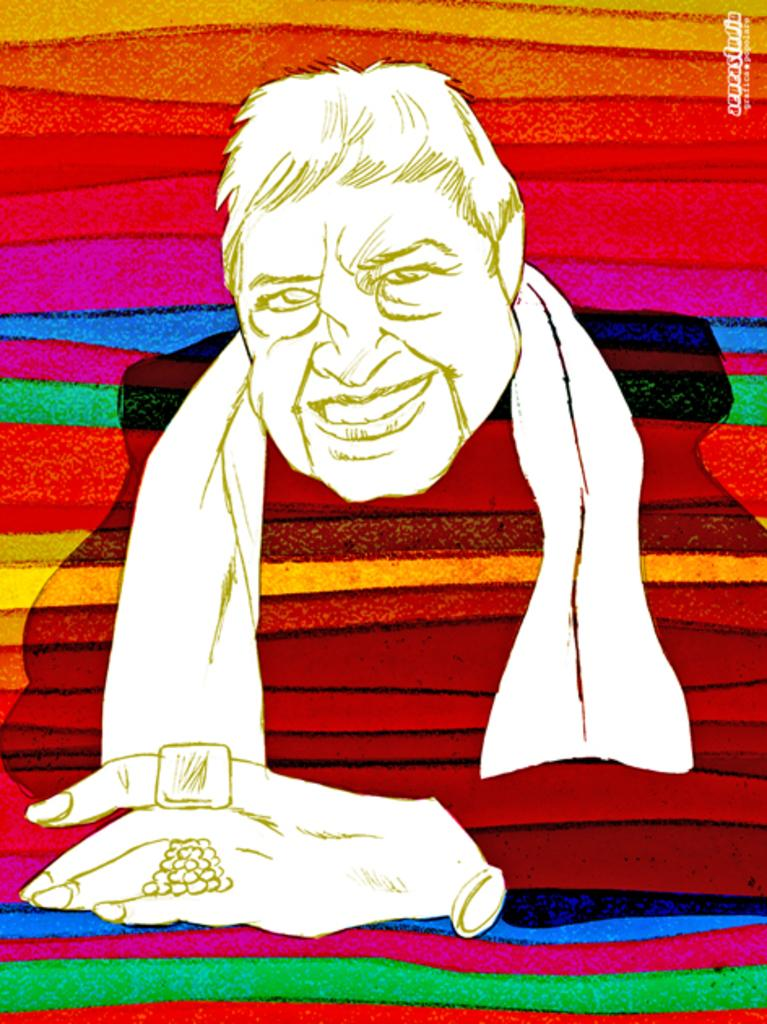What type of image is being described? The image is graphical in nature. What can be seen in the graphical image? There is a depiction of a person in the image. Where is the text located in the image? The text is at the top right of the image. What type of stick is being used by the person in the image? There is no stick present in the image; it only depicts a person. What type of juice is being consumed by the person in the image? There is no juice present in the image; it only depicts a person. 